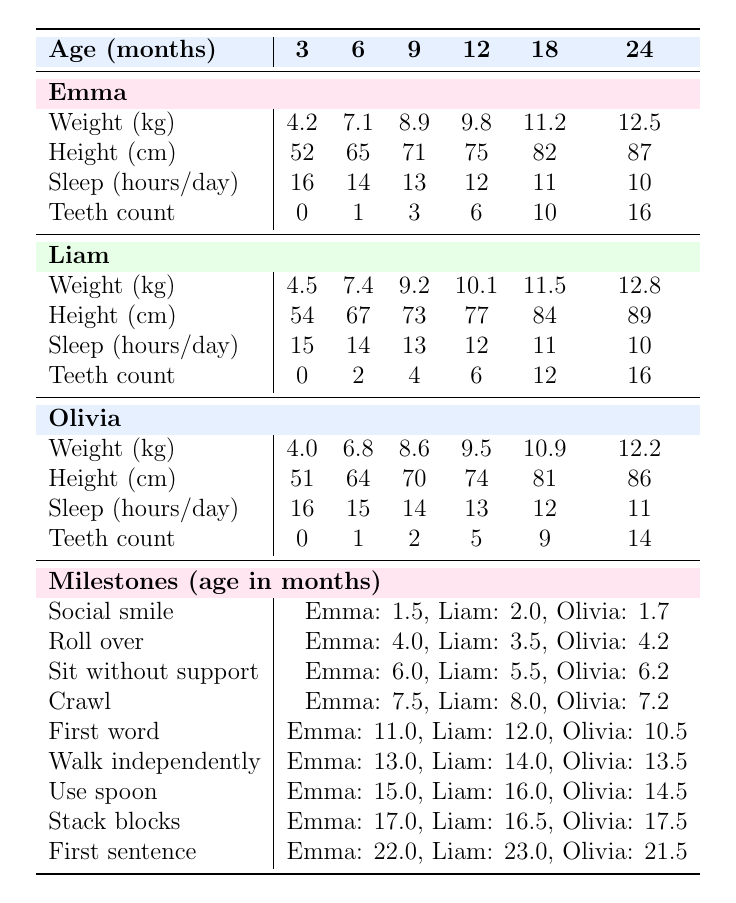What is the weight of Emma at 12 months? According to the table, Emma's weight at 12 months is listed as 9.8 kg.
Answer: 9.8 kg At what age did Liam first say a word? The table shows that Liam said his first word at 12 months.
Answer: 12 months Who crawled the earliest among the triplets? By comparing the crawl milestones, Emma crawled at 7.5 months, which is earlier than Liam's 8 months and Olivia's 7.2 months. Hence, Emma crawled the earliest.
Answer: Emma What is the average height of the triplets at 6 months? Emma's height at 6 months is 65 cm, Liam's is 67 cm, and Olivia's is 64 cm. The average height is (65 + 67 + 64) / 3 = 65.33 cm.
Answer: 65.33 cm Did all triplets have at least one tooth by 12 months? The table shows that Emma had 6 teeth, Liam had 6 teeth, and Olivia had 5 teeth at 12 months; all had at least one tooth.
Answer: Yes What is the difference in weight between Liam and Olivia at 18 months? Liam's weight at 18 months is 11.5 kg and Olivia's is 10.9 kg. The difference is 11.5 - 10.9 = 0.6 kg.
Answer: 0.6 kg At what age did Olivia first walk independently? The milestone for walking independently states Olivia did this at 13.5 months.
Answer: 13.5 months Who had the highest teeth count at 24 months? At 24 months, Emma has 16 teeth, Liam also has 16 teeth, and Olivia has 14 teeth. Since Emma and Liam have the highest with 16 teeth, and both tie, we can say they both had the highest count.
Answer: Emma and Liam How much weight did Emma gain from 12 months to 24 months? Emma's weight increased from 9.8 kg at 12 months to 12.5 kg at 24 months. The gain is 12.5 - 9.8 = 2.7 kg.
Answer: 2.7 kg What is the trend in sleep hours per day for the triplets from 3 months to 24 months? Reviewing the data, Emma sleeps from 16 hours at 3 months down to 10 hours at 24 months; Liam shows a similar trend from 15 to 10 hours, while Olivia goes from 16 to 11 hours. All show a decrease in sleep hours over time.
Answer: Decrease in sleep hours 